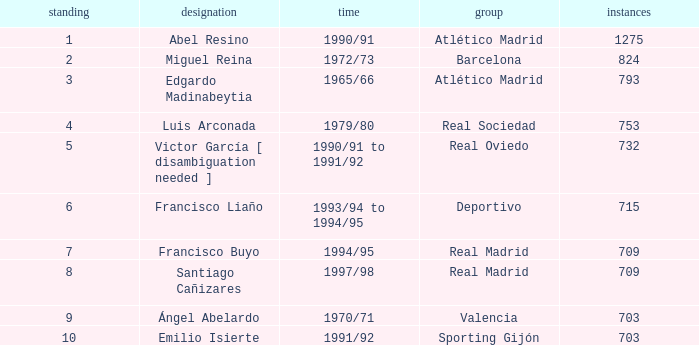What are the on-field minutes of the real madrid club player with a rating of 7 or greater? 709.0. 